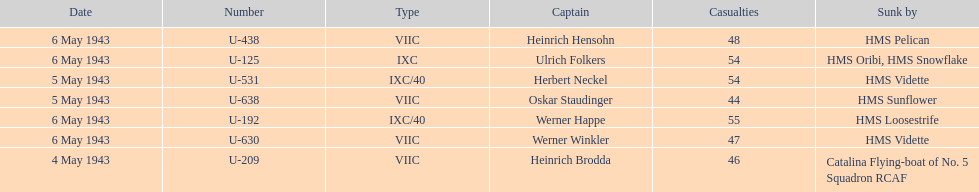Which u-boat had more than 54 casualties? U-192. 